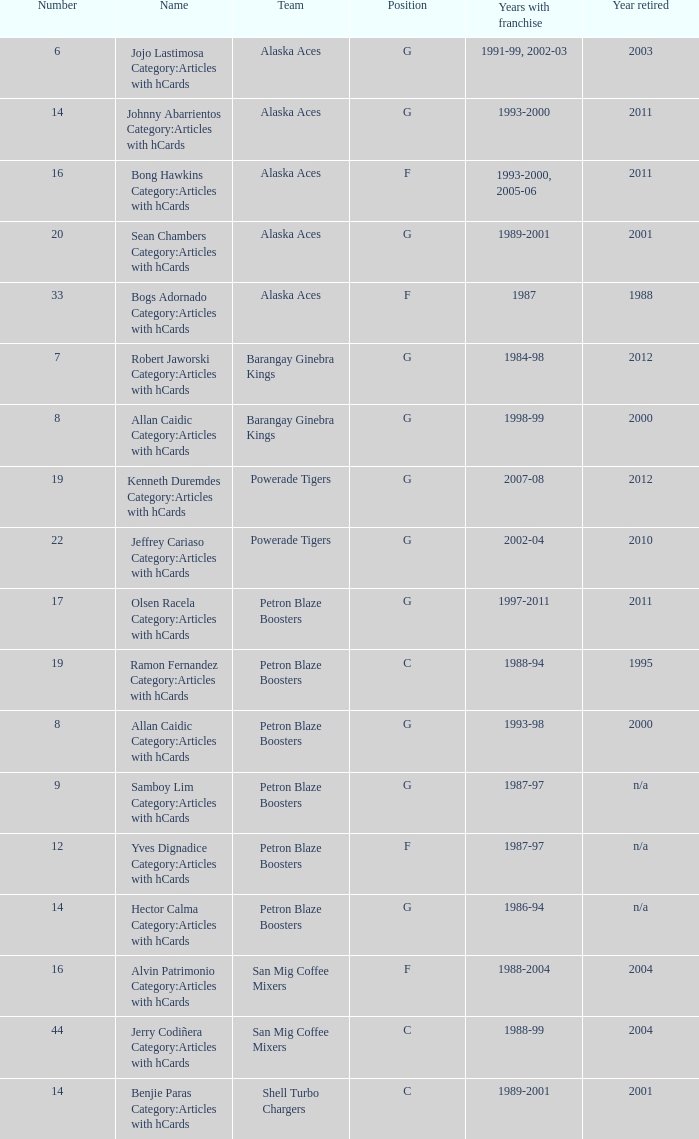Who was the player in Position G on the Petron Blaze Boosters and retired in 2000? Allan Caidic Category:Articles with hCards. 